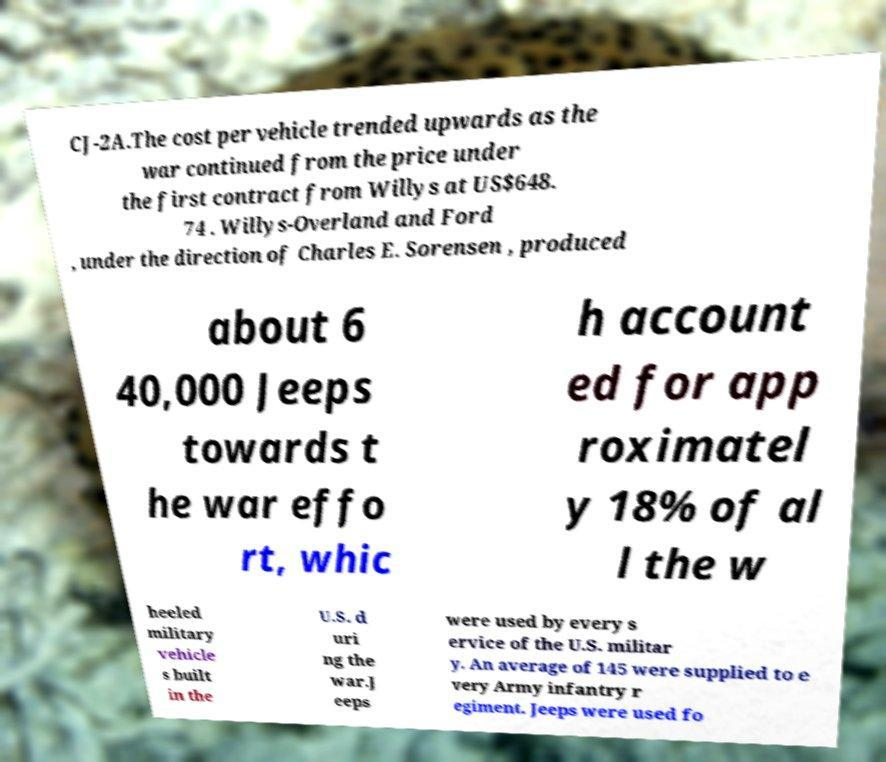Please read and relay the text visible in this image. What does it say? CJ-2A.The cost per vehicle trended upwards as the war continued from the price under the first contract from Willys at US$648. 74 . Willys-Overland and Ford , under the direction of Charles E. Sorensen , produced about 6 40,000 Jeeps towards t he war effo rt, whic h account ed for app roximatel y 18% of al l the w heeled military vehicle s built in the U.S. d uri ng the war.J eeps were used by every s ervice of the U.S. militar y. An average of 145 were supplied to e very Army infantry r egiment. Jeeps were used fo 